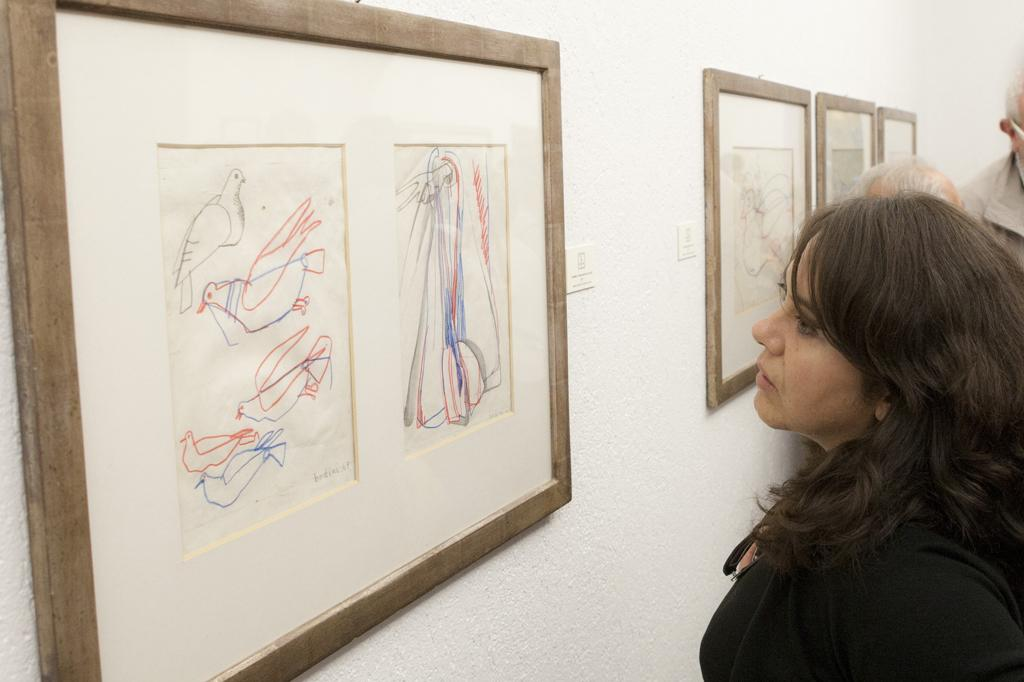What is present in the image? There are people in the image. What can be seen on the wall in the image? There are frames on the wall in the image. What type of rod is being used to increase the size of the bottle in the image? There is no rod or bottle present in the image. 